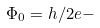<formula> <loc_0><loc_0><loc_500><loc_500>\Phi _ { 0 } = h / 2 e -</formula> 